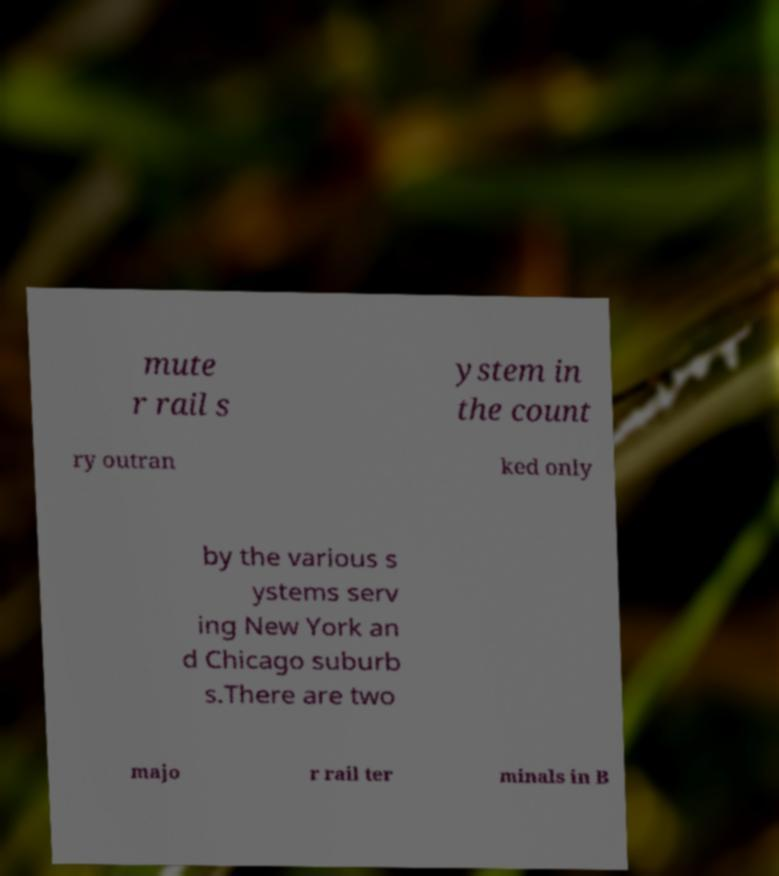Could you extract and type out the text from this image? mute r rail s ystem in the count ry outran ked only by the various s ystems serv ing New York an d Chicago suburb s.There are two majo r rail ter minals in B 